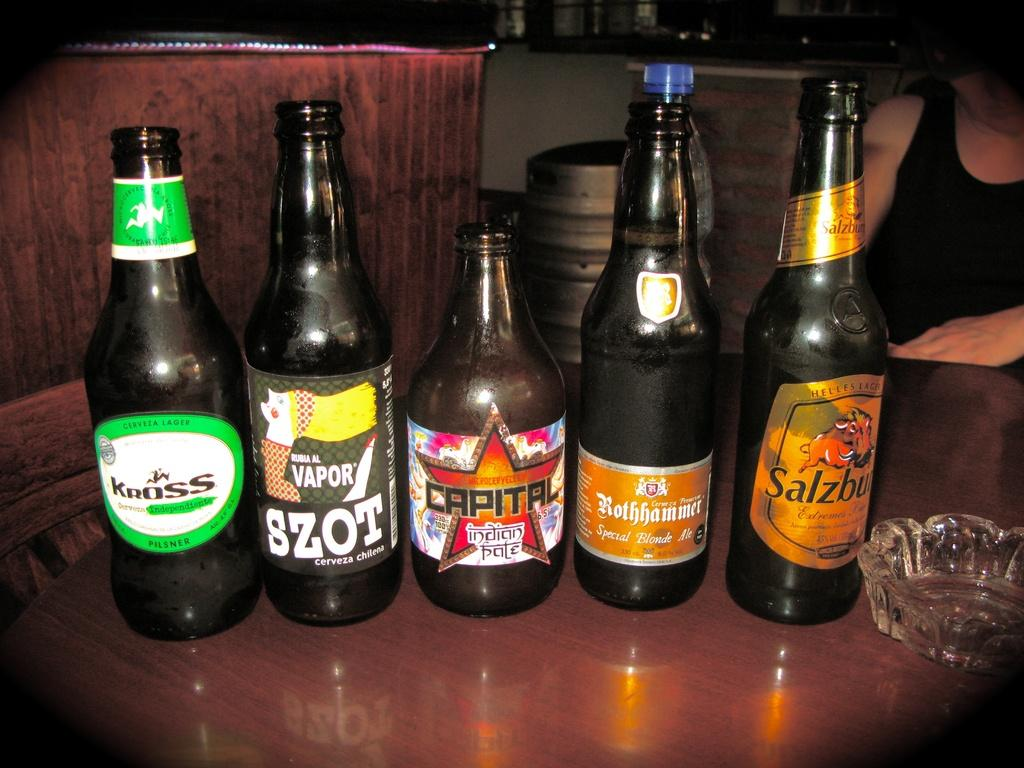<image>
Relay a brief, clear account of the picture shown. Several bottles of beverages one called Vapor are lined up on table. 